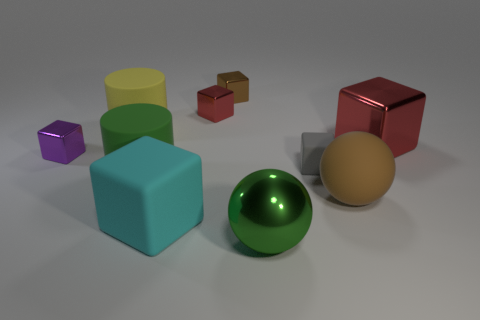Is there anything else that is the same size as the brown ball?
Provide a short and direct response. Yes. There is a ball in front of the big matte cube; does it have the same size as the rubber cube that is in front of the big green matte thing?
Provide a succinct answer. Yes. Are there more big cyan rubber objects that are in front of the big green metallic sphere than big red shiny things that are in front of the small gray matte thing?
Offer a very short reply. No. How many other things are the same color as the metallic ball?
Your response must be concise. 1. Does the small matte block have the same color as the small metal object that is in front of the small red metallic cube?
Your response must be concise. No. There is a matte cube right of the green sphere; how many tiny brown metallic things are right of it?
Your response must be concise. 0. Is there any other thing that has the same material as the large red thing?
Ensure brevity in your answer.  Yes. There is a green thing that is right of the red metallic cube behind the big cylinder that is behind the gray object; what is its material?
Offer a terse response. Metal. What is the material of the big thing that is to the left of the green metal sphere and behind the small purple cube?
Provide a succinct answer. Rubber. How many green matte objects have the same shape as the large yellow object?
Offer a very short reply. 1. 